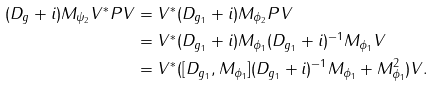<formula> <loc_0><loc_0><loc_500><loc_500>( D _ { g } + i ) M _ { \psi _ { 2 } } V ^ { * } P V & = V ^ { * } ( D _ { g _ { 1 } } + i ) M _ { \phi _ { 2 } } P V \\ & = V ^ { * } ( D _ { g _ { 1 } } + i ) M _ { \phi _ { 1 } } ( D _ { g _ { 1 } } + i ) ^ { - 1 } M _ { \phi _ { 1 } } V \\ & = V ^ { * } ( [ D _ { g _ { 1 } } , M _ { \phi _ { 1 } } ] ( D _ { g _ { 1 } } + i ) ^ { - 1 } M _ { \phi _ { 1 } } + M _ { \phi _ { 1 } } ^ { 2 } ) V .</formula> 